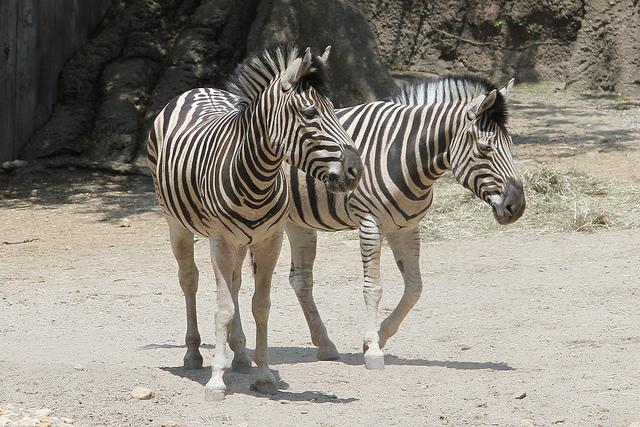Where are the giraffes?
Concise answer only. Nowhere. How many zebras are in the photo?
Keep it brief. 2. Which way is the zebra on the right facing?
Quick response, please. Right. Are the zebras awake?
Give a very brief answer. Yes. Is this a picture of zebra in their natural habitat?
Concise answer only. No. How many zebras are there?
Answer briefly. 2. How many zebra are standing in unison?
Write a very short answer. 2. Are the zebras looking right or left?
Be succinct. Right. Can you see the front of the animal?
Keep it brief. Yes. Is the zebra alone?
Give a very brief answer. No. What are the zebras doing?
Write a very short answer. Walking. Where are these zebras located?
Keep it brief. Zoo. 